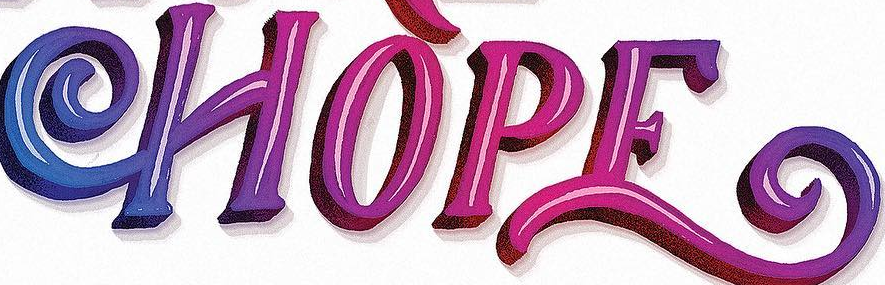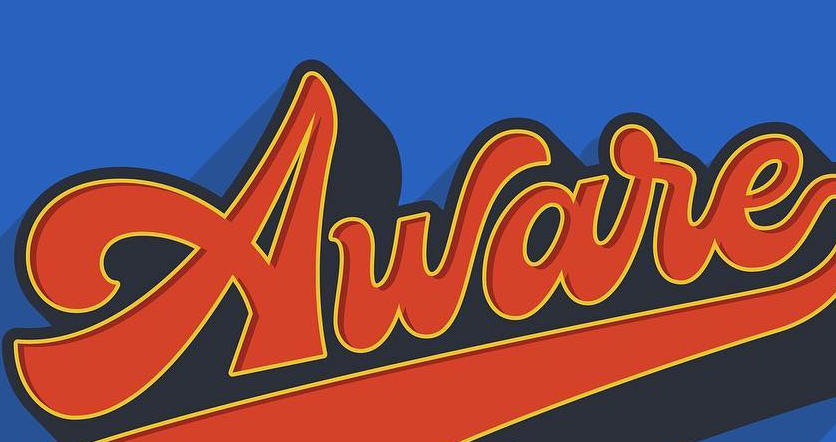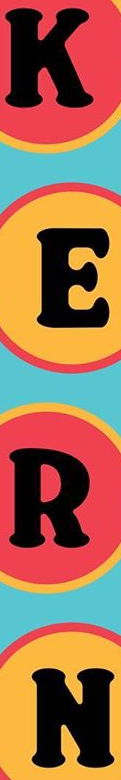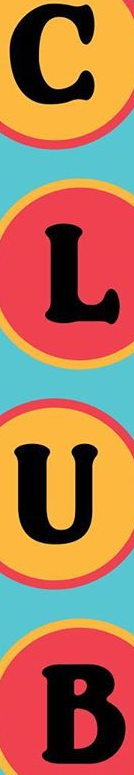What text appears in these images from left to right, separated by a semicolon? HOPE; Aware; KERT; CLUB 